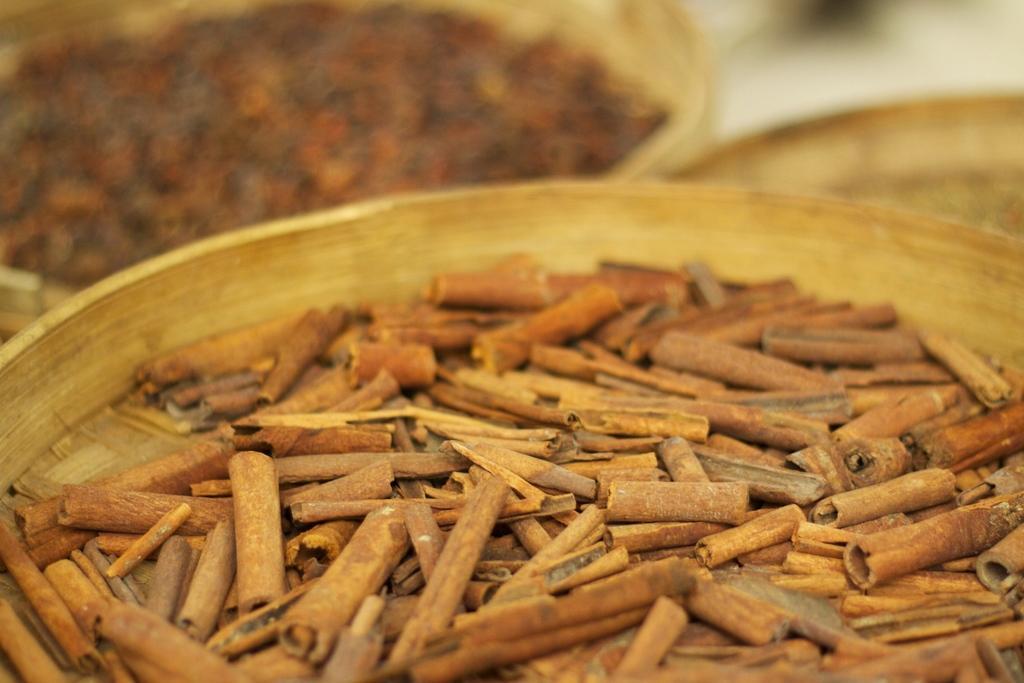Could you give a brief overview of what you see in this image? In this image, we can see a plate, in that place we can see some cinnamon's. 